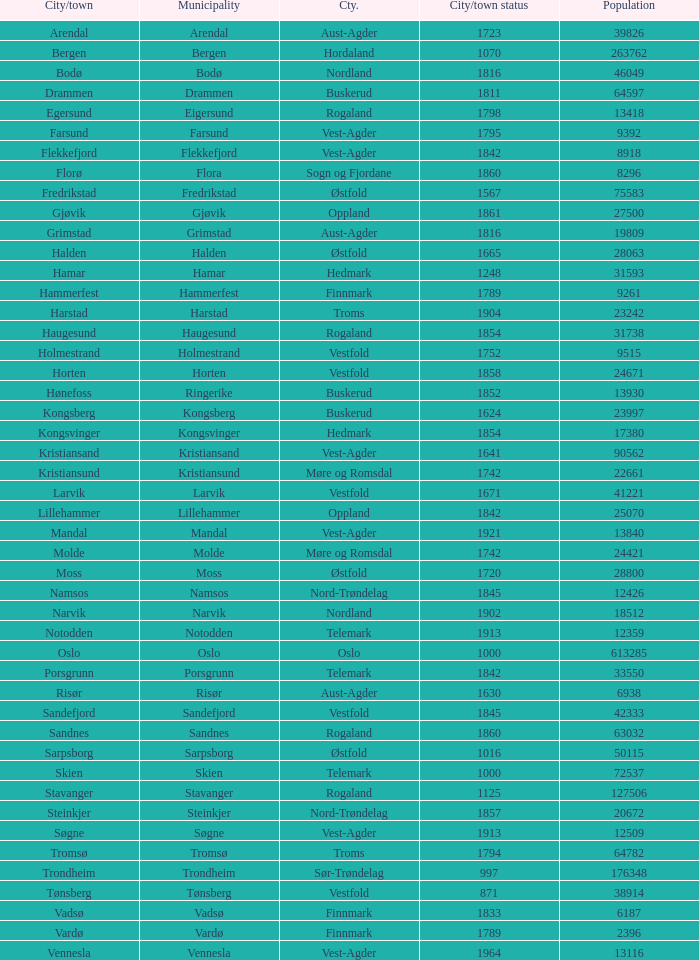In the municipality of horten, what are the various towns or cities situated there? Horten. 